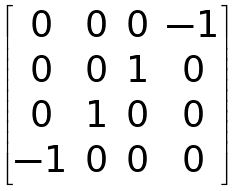<formula> <loc_0><loc_0><loc_500><loc_500>\begin{bmatrix} 0 & 0 & 0 & - 1 \\ 0 & 0 & 1 & 0 \\ 0 & 1 & 0 & 0 \\ - 1 & 0 & 0 & 0 \\ \end{bmatrix}</formula> 